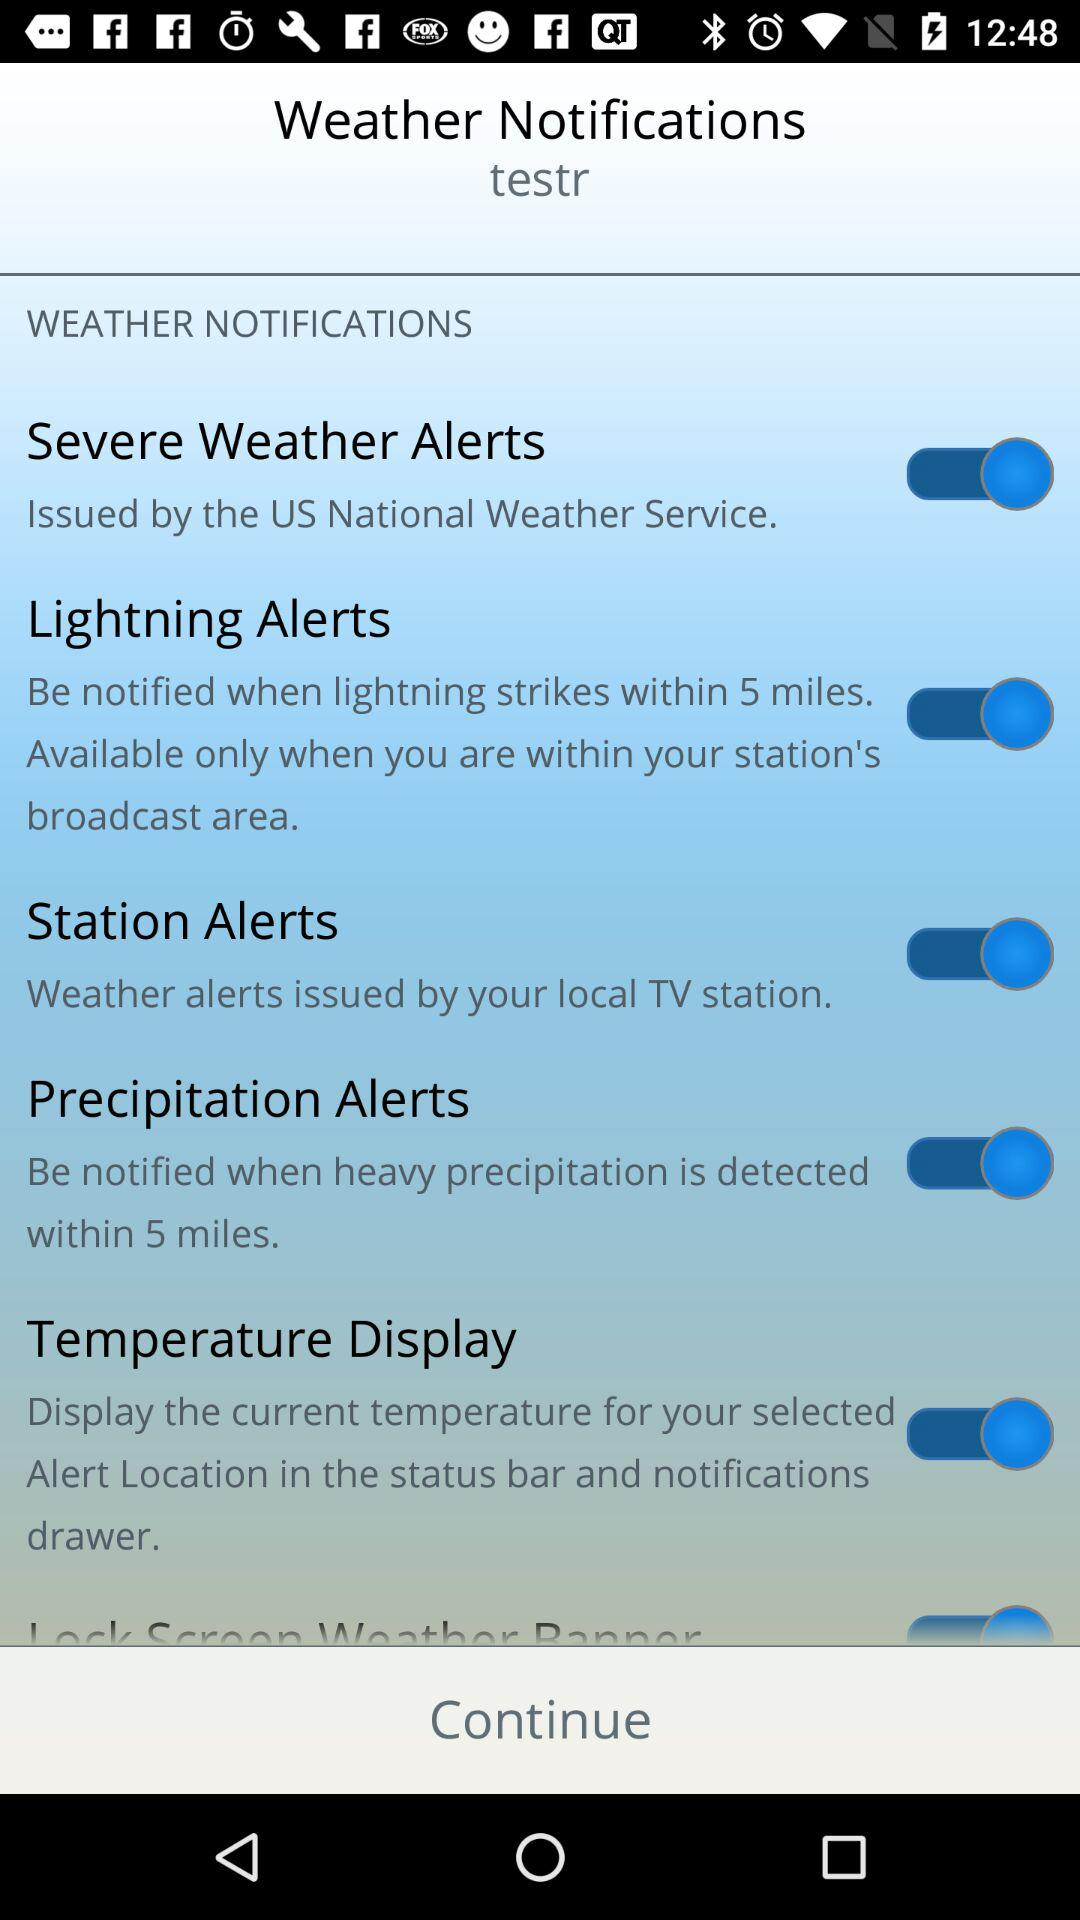How many types of weather alerts are there?
Answer the question using a single word or phrase. 4 